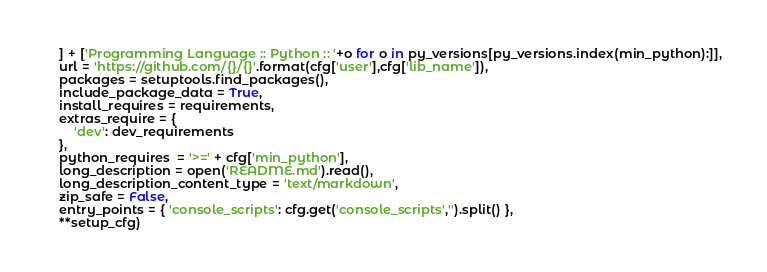Convert code to text. <code><loc_0><loc_0><loc_500><loc_500><_Python_>    ] + ['Programming Language :: Python :: '+o for o in py_versions[py_versions.index(min_python):]],
    url = 'https://github.com/{}/{}'.format(cfg['user'],cfg['lib_name']),
    packages = setuptools.find_packages(),
    include_package_data = True,
    install_requires = requirements,
    extras_require = {
        'dev': dev_requirements
    },
    python_requires  = '>=' + cfg['min_python'],
    long_description = open('README.md').read(),
    long_description_content_type = 'text/markdown',
    zip_safe = False,
    entry_points = { 'console_scripts': cfg.get('console_scripts','').split() },
    **setup_cfg)

</code> 